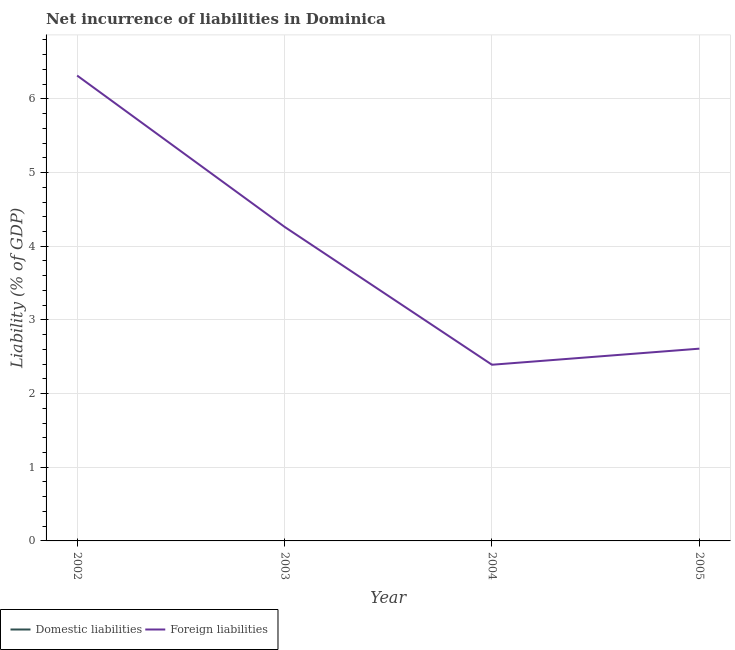How many different coloured lines are there?
Your answer should be compact. 1. Does the line corresponding to incurrence of foreign liabilities intersect with the line corresponding to incurrence of domestic liabilities?
Keep it short and to the point. No. Is the number of lines equal to the number of legend labels?
Your answer should be compact. No. What is the incurrence of foreign liabilities in 2002?
Keep it short and to the point. 6.32. Across all years, what is the maximum incurrence of foreign liabilities?
Your response must be concise. 6.32. What is the total incurrence of foreign liabilities in the graph?
Offer a terse response. 15.58. What is the difference between the incurrence of foreign liabilities in 2002 and that in 2005?
Ensure brevity in your answer.  3.71. What is the difference between the incurrence of foreign liabilities in 2005 and the incurrence of domestic liabilities in 2004?
Your response must be concise. 2.61. What is the ratio of the incurrence of foreign liabilities in 2004 to that in 2005?
Your answer should be very brief. 0.92. What is the difference between the highest and the second highest incurrence of foreign liabilities?
Your response must be concise. 2.05. Does the incurrence of domestic liabilities monotonically increase over the years?
Ensure brevity in your answer.  No. How many lines are there?
Your answer should be compact. 1. How many years are there in the graph?
Ensure brevity in your answer.  4. Does the graph contain grids?
Offer a terse response. Yes. How many legend labels are there?
Your answer should be compact. 2. What is the title of the graph?
Your answer should be very brief. Net incurrence of liabilities in Dominica. What is the label or title of the Y-axis?
Your answer should be very brief. Liability (% of GDP). What is the Liability (% of GDP) in Foreign liabilities in 2002?
Give a very brief answer. 6.32. What is the Liability (% of GDP) of Foreign liabilities in 2003?
Keep it short and to the point. 4.26. What is the Liability (% of GDP) in Domestic liabilities in 2004?
Keep it short and to the point. 0. What is the Liability (% of GDP) of Foreign liabilities in 2004?
Provide a short and direct response. 2.39. What is the Liability (% of GDP) in Foreign liabilities in 2005?
Provide a succinct answer. 2.61. Across all years, what is the maximum Liability (% of GDP) of Foreign liabilities?
Your answer should be very brief. 6.32. Across all years, what is the minimum Liability (% of GDP) of Foreign liabilities?
Your answer should be compact. 2.39. What is the total Liability (% of GDP) of Foreign liabilities in the graph?
Offer a very short reply. 15.58. What is the difference between the Liability (% of GDP) of Foreign liabilities in 2002 and that in 2003?
Give a very brief answer. 2.05. What is the difference between the Liability (% of GDP) of Foreign liabilities in 2002 and that in 2004?
Make the answer very short. 3.93. What is the difference between the Liability (% of GDP) of Foreign liabilities in 2002 and that in 2005?
Give a very brief answer. 3.71. What is the difference between the Liability (% of GDP) in Foreign liabilities in 2003 and that in 2004?
Provide a succinct answer. 1.87. What is the difference between the Liability (% of GDP) in Foreign liabilities in 2003 and that in 2005?
Your response must be concise. 1.65. What is the difference between the Liability (% of GDP) in Foreign liabilities in 2004 and that in 2005?
Offer a terse response. -0.22. What is the average Liability (% of GDP) of Domestic liabilities per year?
Give a very brief answer. 0. What is the average Liability (% of GDP) in Foreign liabilities per year?
Your response must be concise. 3.9. What is the ratio of the Liability (% of GDP) in Foreign liabilities in 2002 to that in 2003?
Offer a very short reply. 1.48. What is the ratio of the Liability (% of GDP) in Foreign liabilities in 2002 to that in 2004?
Keep it short and to the point. 2.64. What is the ratio of the Liability (% of GDP) in Foreign liabilities in 2002 to that in 2005?
Provide a succinct answer. 2.42. What is the ratio of the Liability (% of GDP) in Foreign liabilities in 2003 to that in 2004?
Keep it short and to the point. 1.78. What is the ratio of the Liability (% of GDP) of Foreign liabilities in 2003 to that in 2005?
Give a very brief answer. 1.63. What is the ratio of the Liability (% of GDP) of Foreign liabilities in 2004 to that in 2005?
Give a very brief answer. 0.92. What is the difference between the highest and the second highest Liability (% of GDP) of Foreign liabilities?
Your response must be concise. 2.05. What is the difference between the highest and the lowest Liability (% of GDP) in Foreign liabilities?
Give a very brief answer. 3.93. 